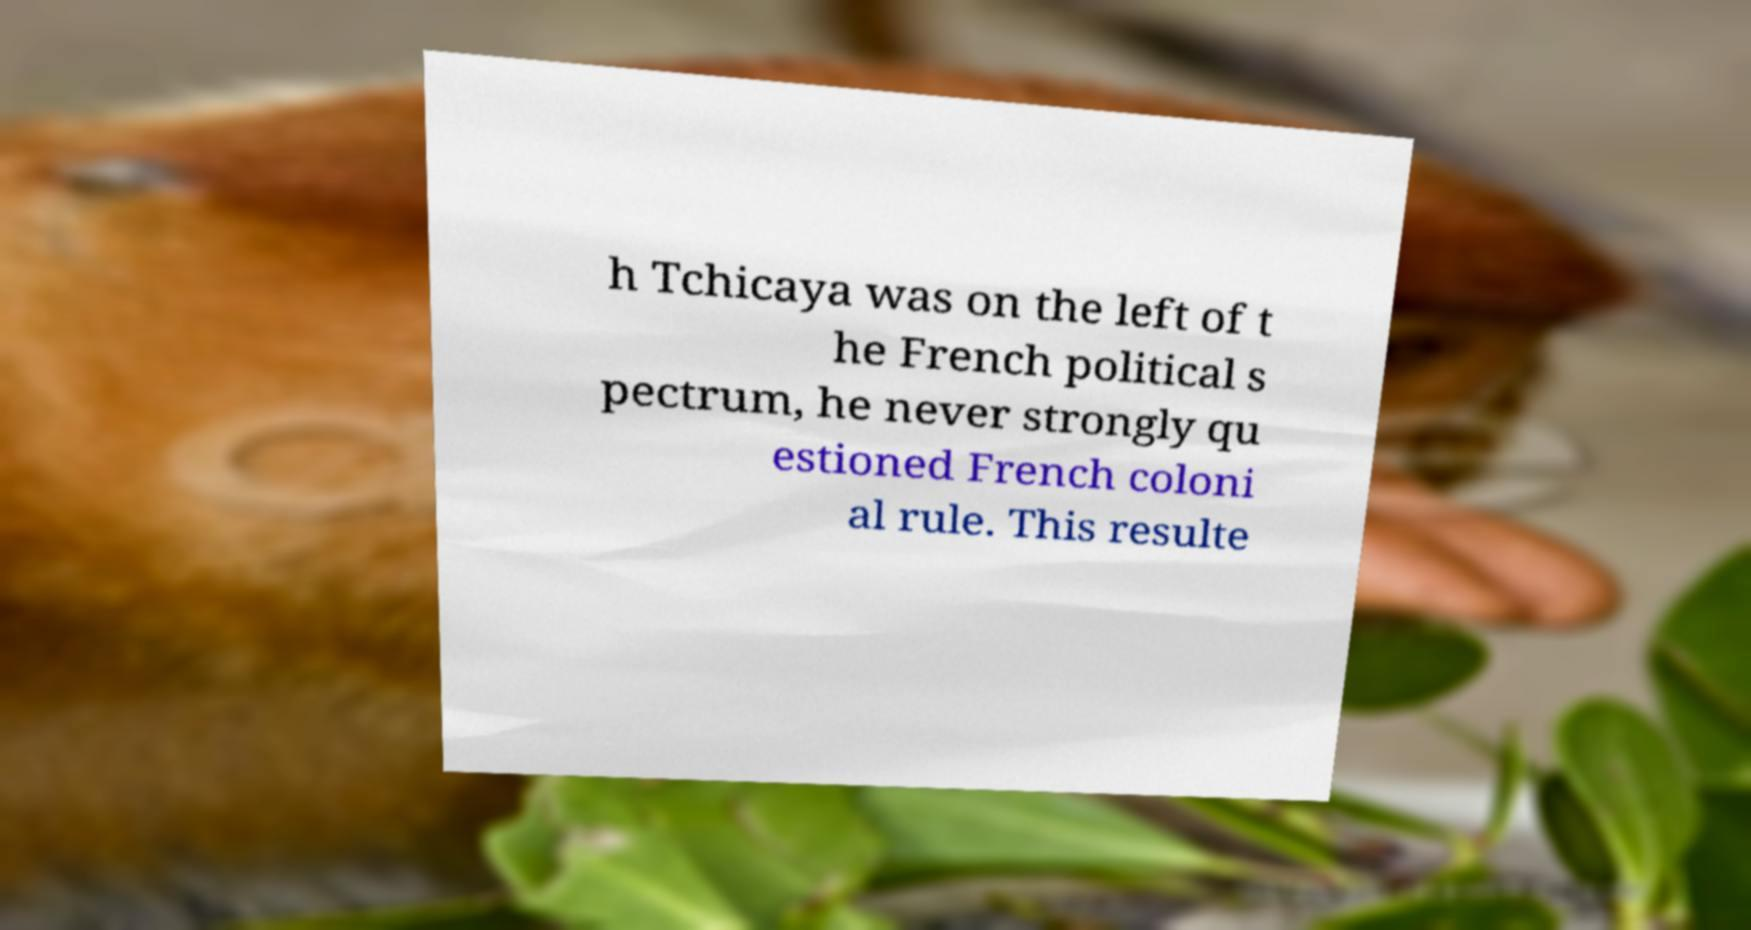Can you accurately transcribe the text from the provided image for me? h Tchicaya was on the left of t he French political s pectrum, he never strongly qu estioned French coloni al rule. This resulte 